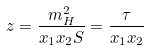Convert formula to latex. <formula><loc_0><loc_0><loc_500><loc_500>z = \frac { m _ { H } ^ { 2 } } { x _ { 1 } x _ { 2 } S } = \frac { \tau } { x _ { 1 } x _ { 2 } }</formula> 